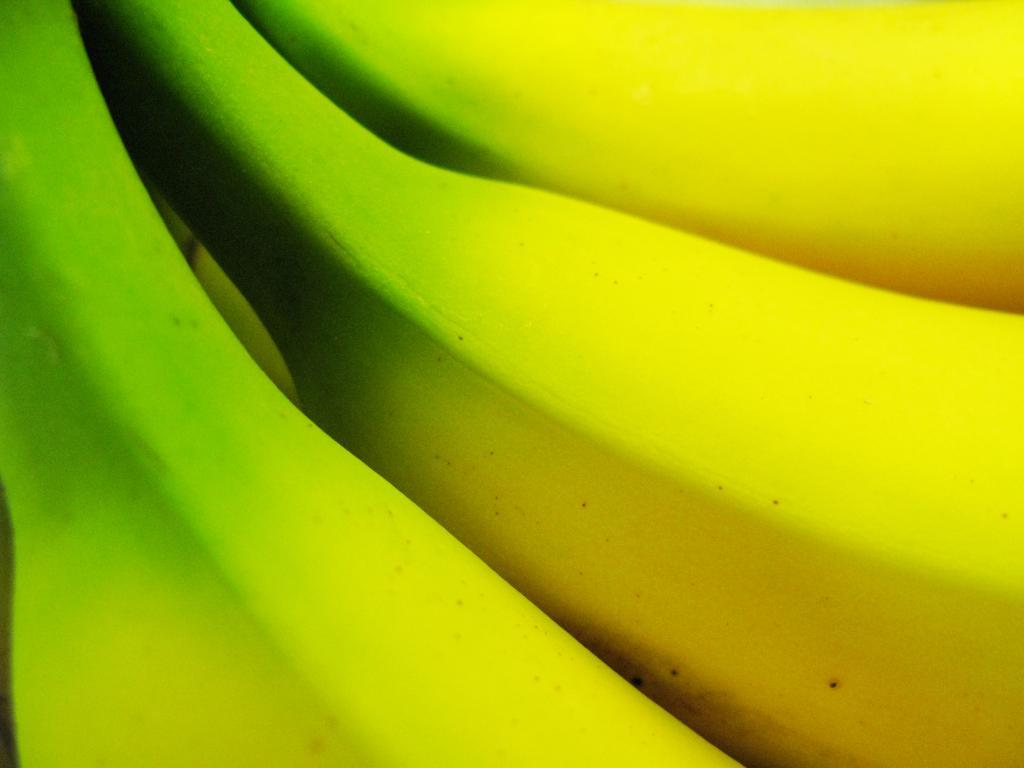What type of fruit is present in the image? There are bananas in the image. How many bananas can be seen in the image? The number of bananas is not specified, but there are bananas present in the image. What color are the bananas in the image? The color of the bananas is not mentioned, but bananas are typically yellow or green. What scientific theory is being discussed in the image? There is no indication of a scientific theory being discussed in the image, as it only features bananas. 